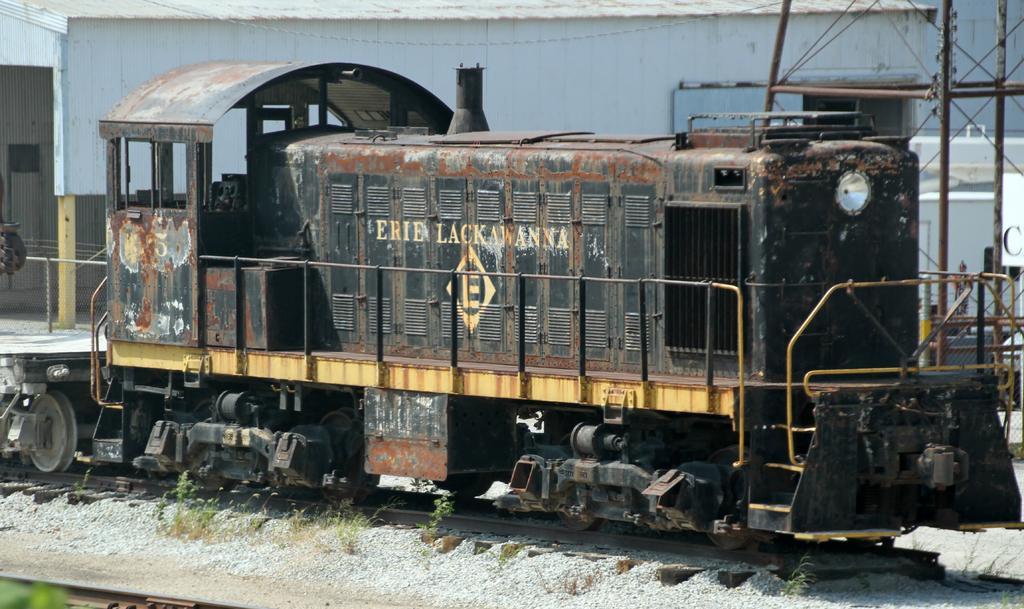Can you describe this image briefly? In this picture there is a old and damaged train engine is parked on the track. Behind there is a white color shed warehouse. 